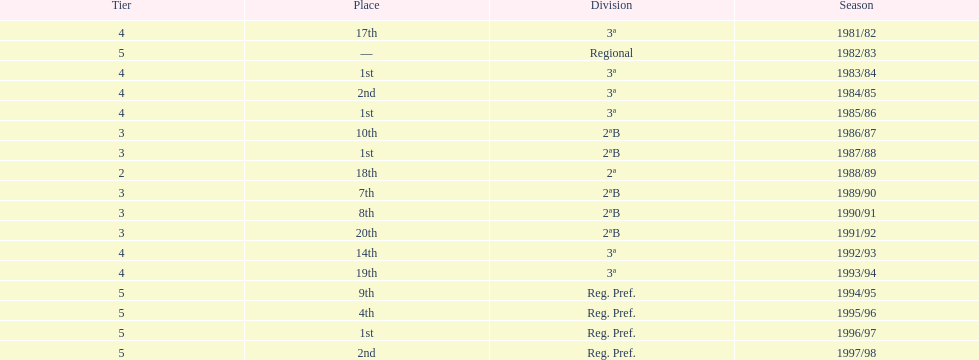Which season(s) earned first place? 1983/84, 1985/86, 1987/88, 1996/97. 